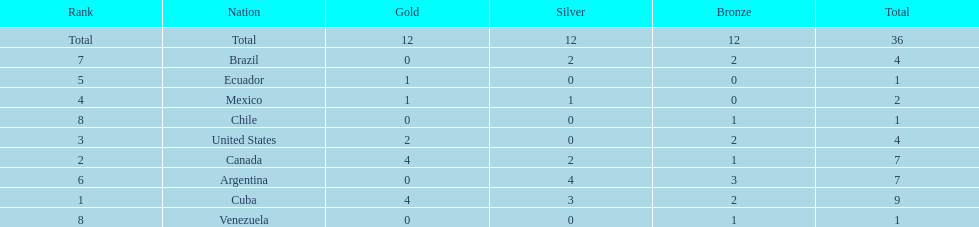How many total medals did argentina win? 7. 